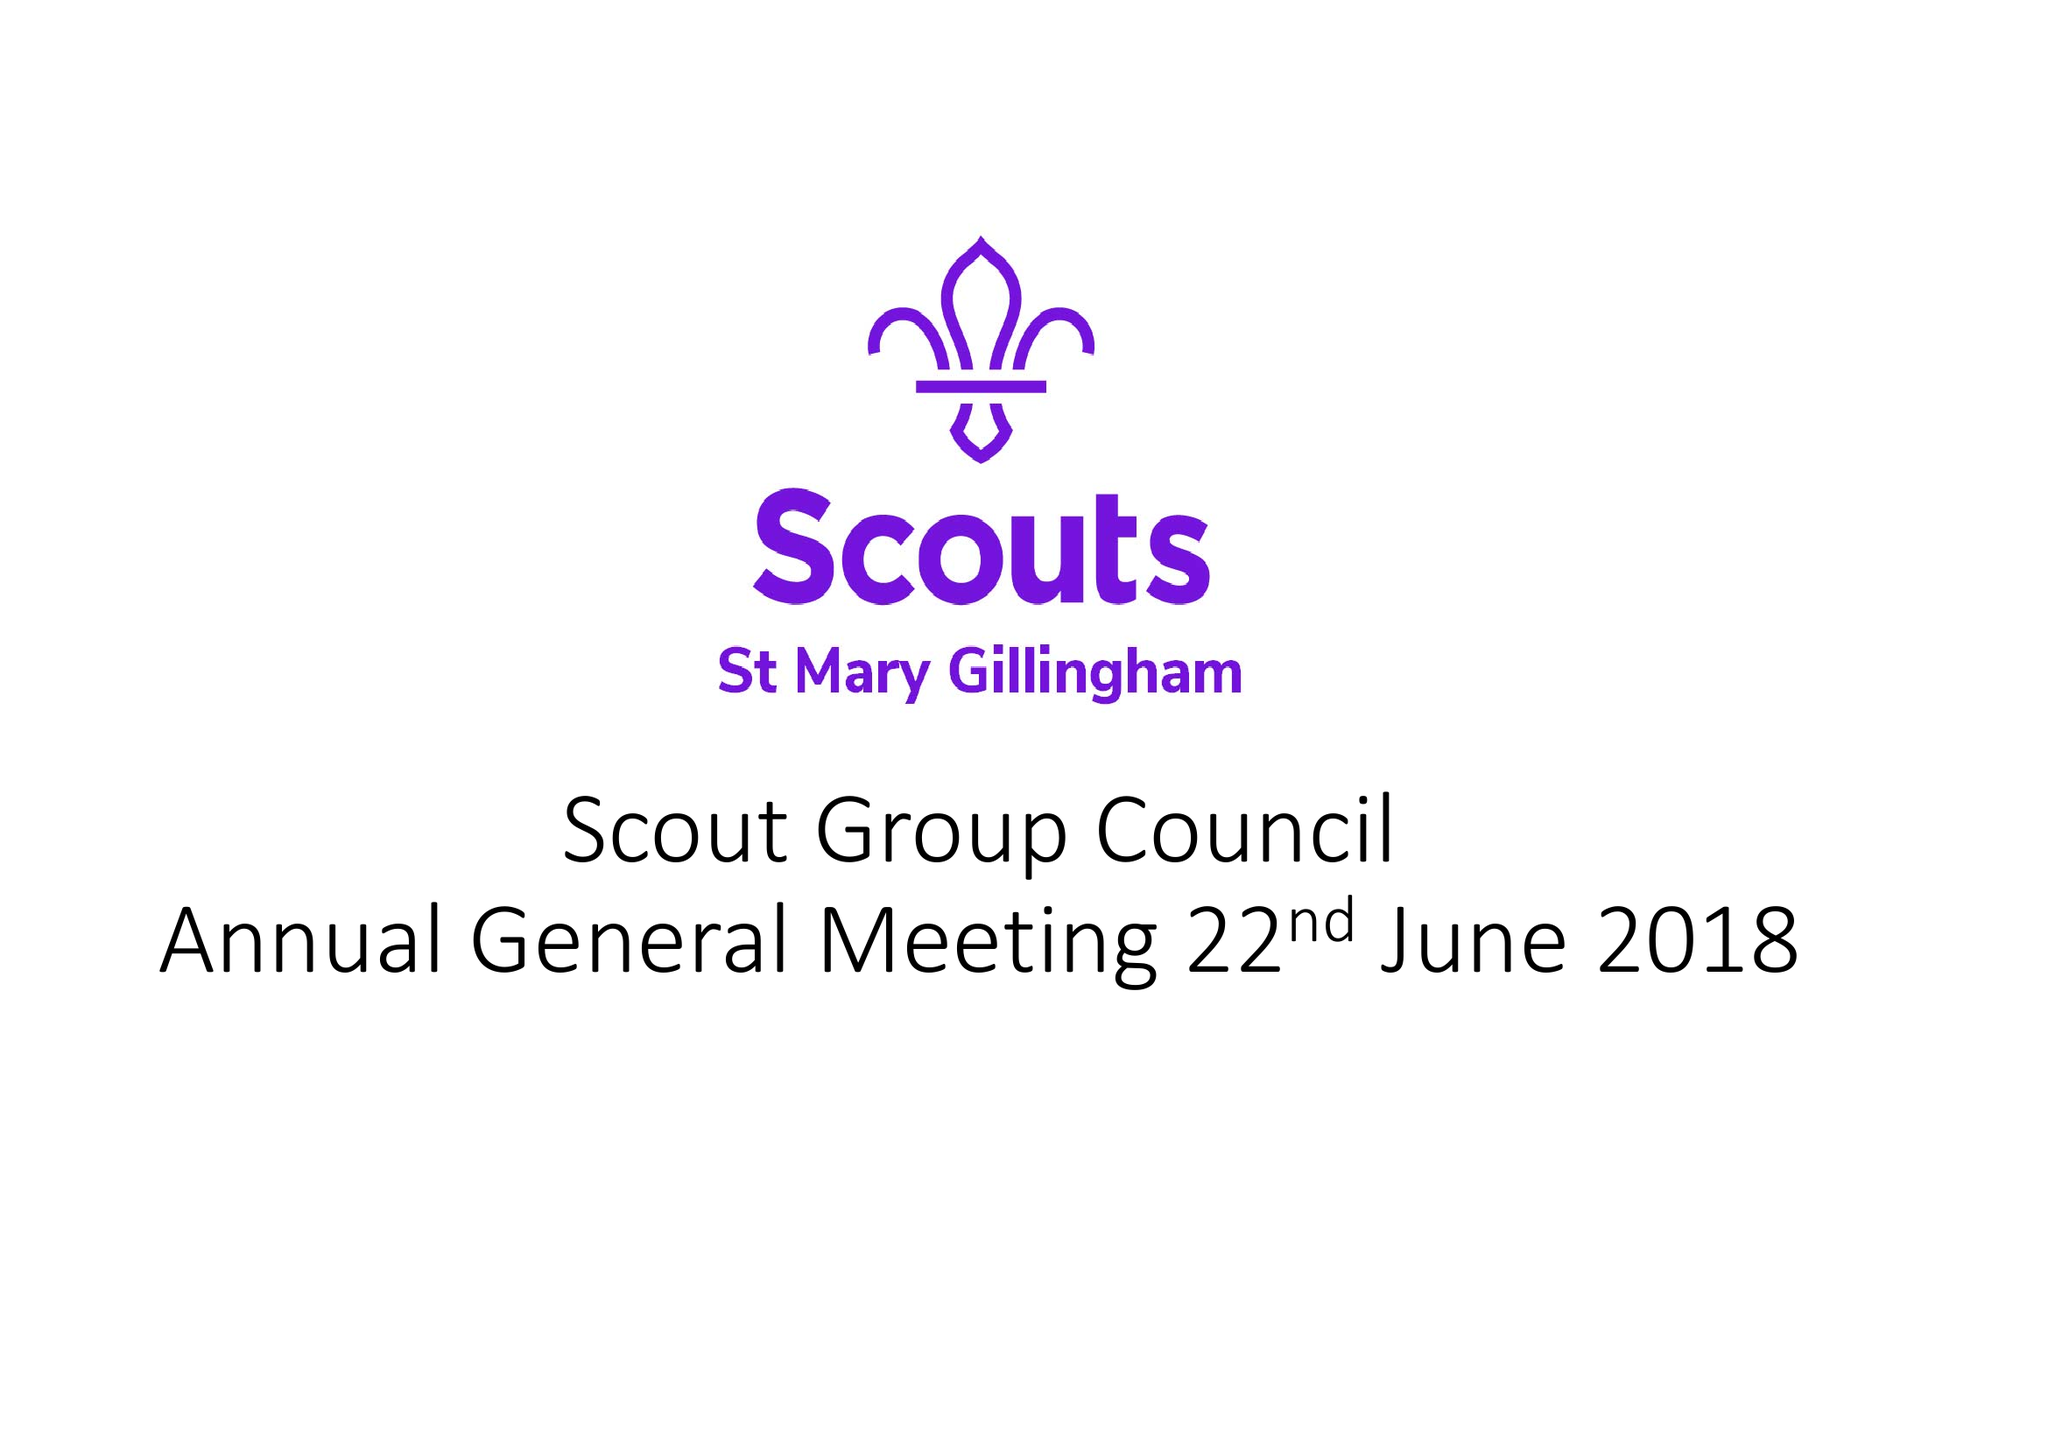What is the value for the address__post_town?
Answer the question using a single word or phrase. None 